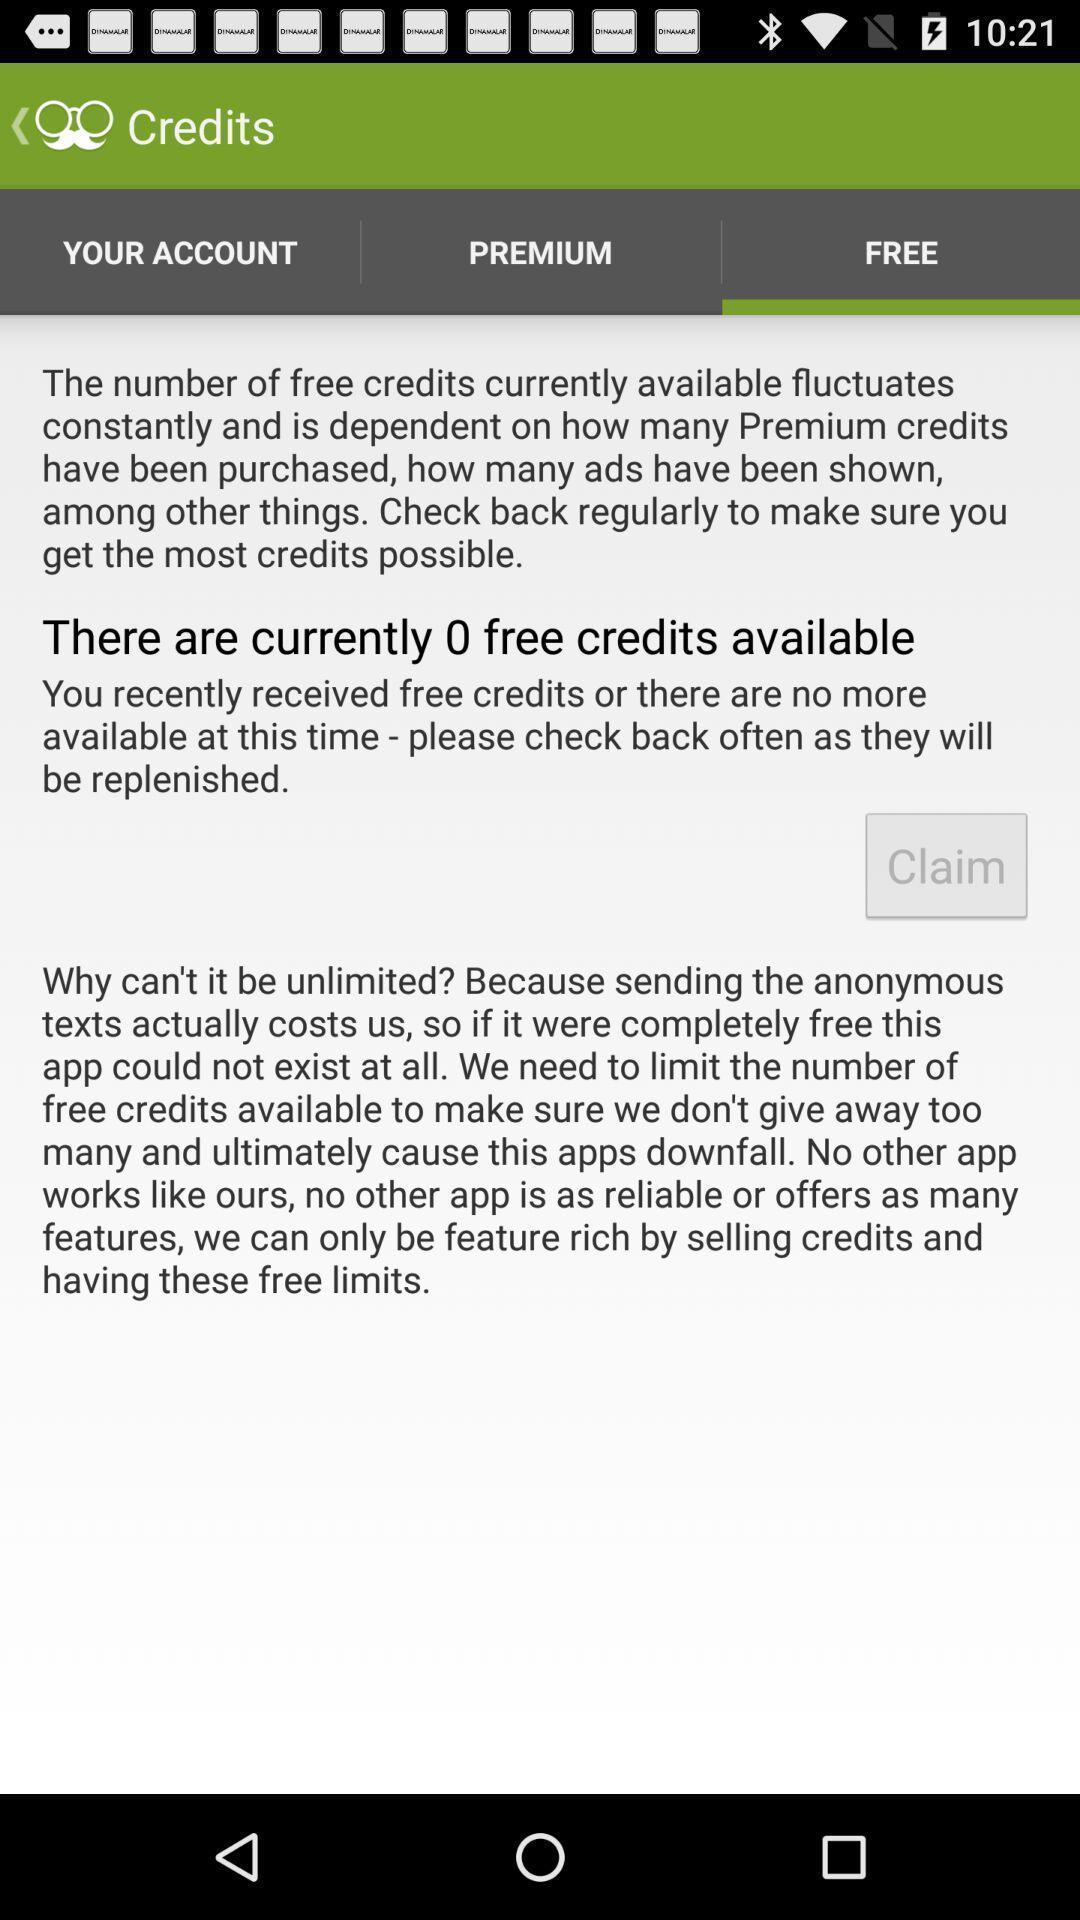Explain the elements present in this screenshot. Screen display free credits page of a social app. 